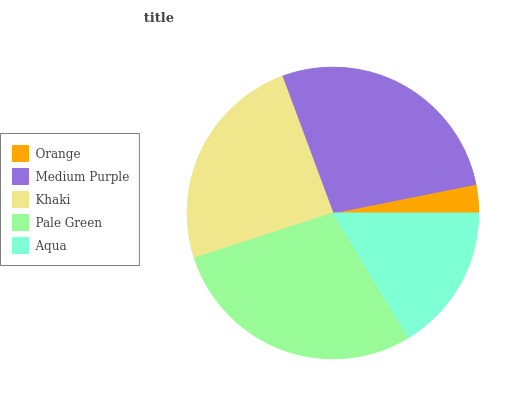Is Orange the minimum?
Answer yes or no. Yes. Is Pale Green the maximum?
Answer yes or no. Yes. Is Medium Purple the minimum?
Answer yes or no. No. Is Medium Purple the maximum?
Answer yes or no. No. Is Medium Purple greater than Orange?
Answer yes or no. Yes. Is Orange less than Medium Purple?
Answer yes or no. Yes. Is Orange greater than Medium Purple?
Answer yes or no. No. Is Medium Purple less than Orange?
Answer yes or no. No. Is Khaki the high median?
Answer yes or no. Yes. Is Khaki the low median?
Answer yes or no. Yes. Is Orange the high median?
Answer yes or no. No. Is Orange the low median?
Answer yes or no. No. 